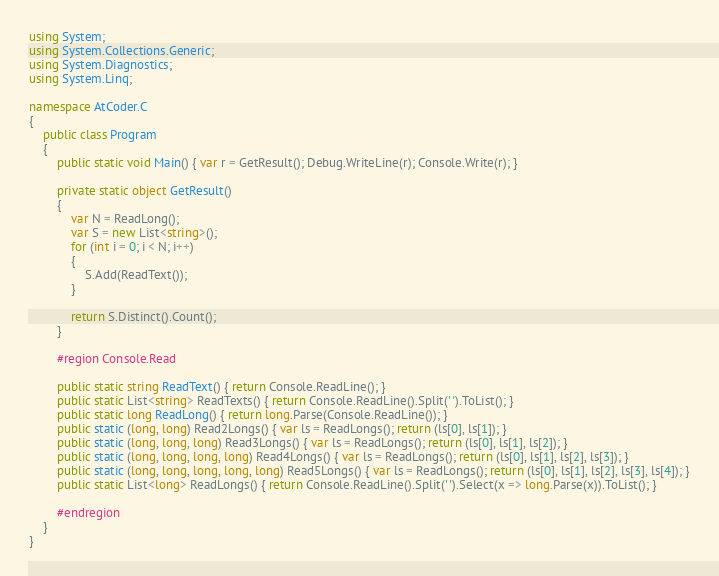<code> <loc_0><loc_0><loc_500><loc_500><_C#_>using System;
using System.Collections.Generic;
using System.Diagnostics;
using System.Linq;

namespace AtCoder.C
{
    public class Program
    {
        public static void Main() { var r = GetResult(); Debug.WriteLine(r); Console.Write(r); }

        private static object GetResult()
        {
            var N = ReadLong();
            var S = new List<string>();
            for (int i = 0; i < N; i++)
            {
                S.Add(ReadText());
            }

            return S.Distinct().Count();
        }

        #region Console.Read

        public static string ReadText() { return Console.ReadLine(); }
        public static List<string> ReadTexts() { return Console.ReadLine().Split(' ').ToList(); }
        public static long ReadLong() { return long.Parse(Console.ReadLine()); }
        public static (long, long) Read2Longs() { var ls = ReadLongs(); return (ls[0], ls[1]); }
        public static (long, long, long) Read3Longs() { var ls = ReadLongs(); return (ls[0], ls[1], ls[2]); }
        public static (long, long, long, long) Read4Longs() { var ls = ReadLongs(); return (ls[0], ls[1], ls[2], ls[3]); }
        public static (long, long, long, long, long) Read5Longs() { var ls = ReadLongs(); return (ls[0], ls[1], ls[2], ls[3], ls[4]); }
        public static List<long> ReadLongs() { return Console.ReadLine().Split(' ').Select(x => long.Parse(x)).ToList(); }

        #endregion
    }
}
</code> 